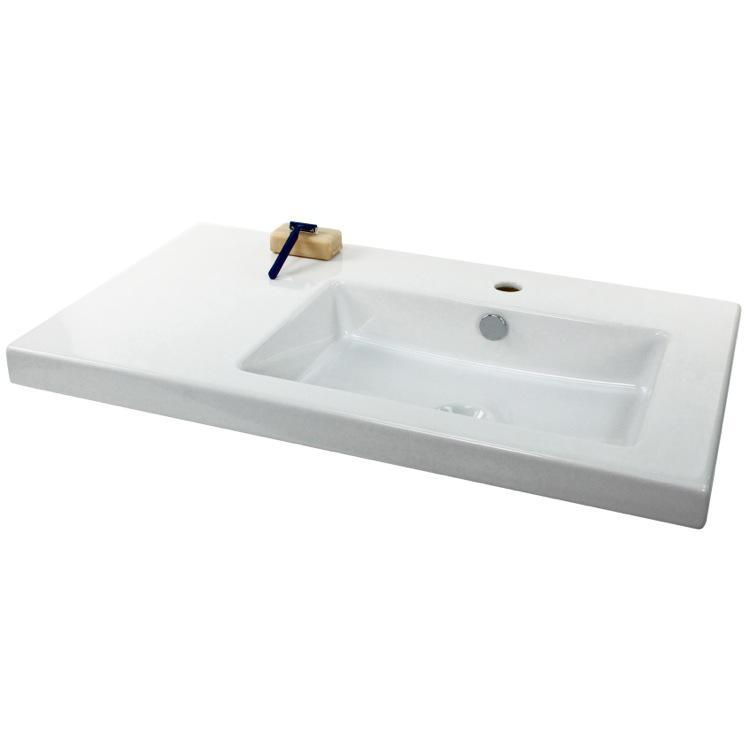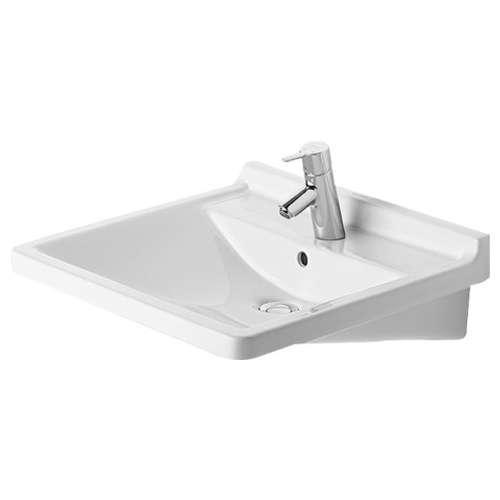The first image is the image on the left, the second image is the image on the right. Analyze the images presented: Is the assertion "At least one sink is more oblong than rectangular, and no sink has a faucet or spout installed." valid? Answer yes or no. No. The first image is the image on the left, the second image is the image on the right. Assess this claim about the two images: "There are two wash basins facing the same direction.". Correct or not? Answer yes or no. No. 